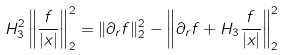Convert formula to latex. <formula><loc_0><loc_0><loc_500><loc_500>H _ { 3 } ^ { 2 } \left \| \frac { f } { | x | } \right \| _ { 2 } ^ { 2 } = \| \partial _ { r } f \| _ { 2 } ^ { 2 } - \left \| \partial _ { r } f + H _ { 3 } \frac { f } { | x | } \right \| _ { 2 } ^ { 2 }</formula> 